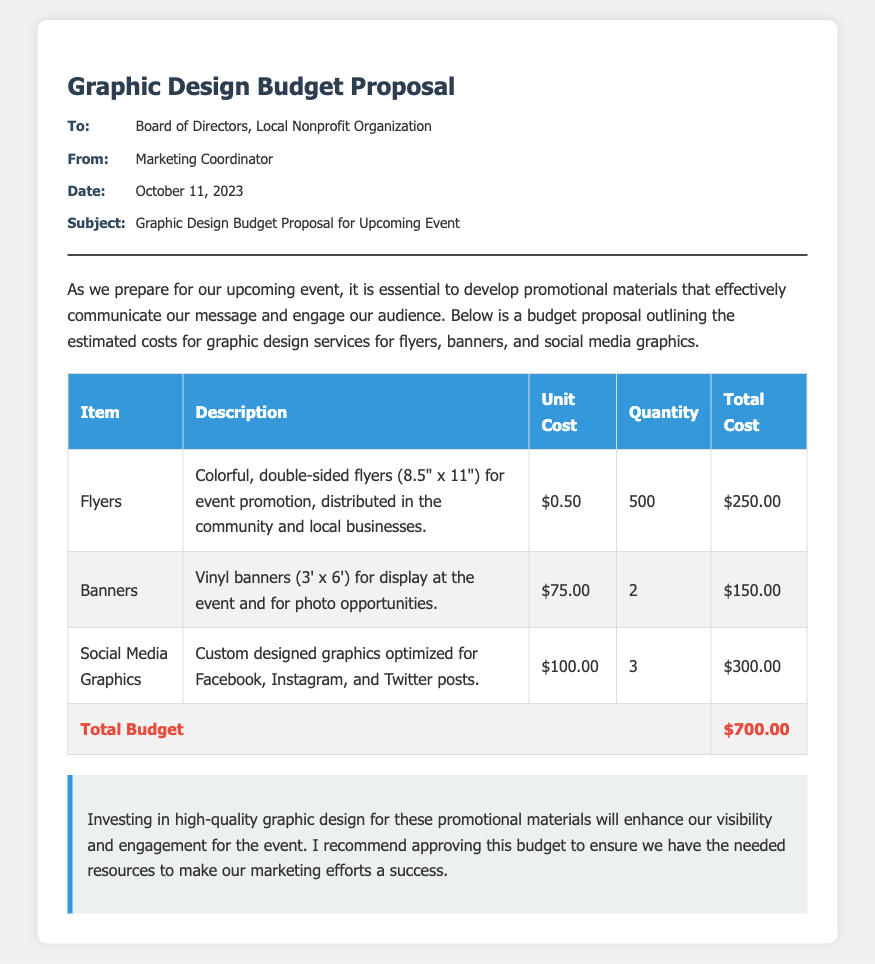what is the total budget? The total budget is found in the summary at the end of the document, which combines all estimated costs.
Answer: $700.00 who is the memo addressed to? The memo is addressed to the Board of Directors of the Local Nonprofit Organization as stated in the recipient section.
Answer: Board of Directors, Local Nonprofit Organization how many banners are included in the proposal? The quantity of banners is stated in the table under the quantity column for the item banners.
Answer: 2 what is the unit cost of flyers? The unit cost of flyers is provided in the table under the unit cost column corresponding to the item flyers.
Answer: $0.50 what type of graphics are included for social media? The document specifies custom designed graphics optimized for Facebook, Instagram, and Twitter posts under the description for social media graphics.
Answer: Custom designed graphics what is the description of the flyers? The description of the flyers can be found in the table detailing their purpose and features.
Answer: Colorful, double-sided flyers (8.5" x 11") for event promotion, distributed in the community and local businesses who created the memo? The sender of the memo is provided in the metadata section, indicating who is responsible for this communication.
Answer: Marketing Coordinator what is the date of the memo? The date is stated in the metadata section and indicates when the memo was created.
Answer: October 11, 2023 what is the total cost of social media graphics? The total cost for social media graphics is mentioned in the table under the total cost column for the respective item.
Answer: $300.00 